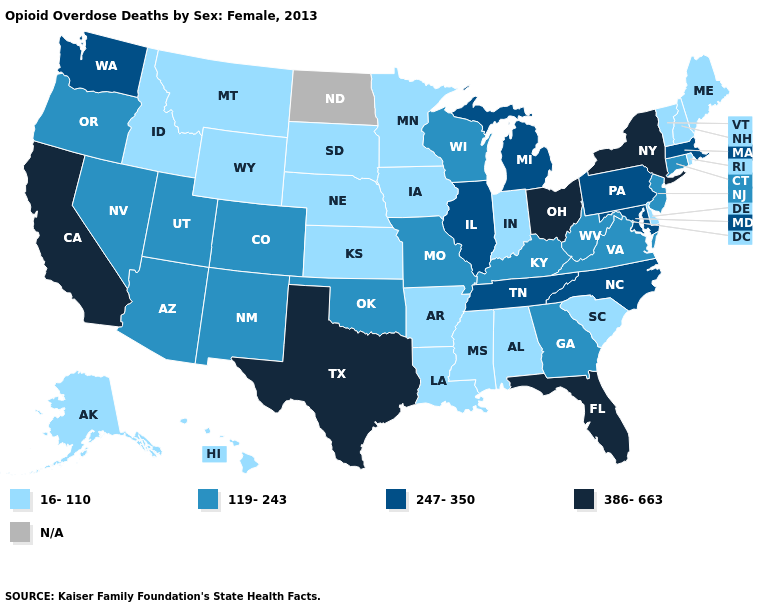Name the states that have a value in the range 16-110?
Keep it brief. Alabama, Alaska, Arkansas, Delaware, Hawaii, Idaho, Indiana, Iowa, Kansas, Louisiana, Maine, Minnesota, Mississippi, Montana, Nebraska, New Hampshire, Rhode Island, South Carolina, South Dakota, Vermont, Wyoming. Among the states that border Oregon , which have the highest value?
Concise answer only. California. Name the states that have a value in the range 119-243?
Keep it brief. Arizona, Colorado, Connecticut, Georgia, Kentucky, Missouri, Nevada, New Jersey, New Mexico, Oklahoma, Oregon, Utah, Virginia, West Virginia, Wisconsin. Name the states that have a value in the range 247-350?
Keep it brief. Illinois, Maryland, Massachusetts, Michigan, North Carolina, Pennsylvania, Tennessee, Washington. Name the states that have a value in the range 247-350?
Be succinct. Illinois, Maryland, Massachusetts, Michigan, North Carolina, Pennsylvania, Tennessee, Washington. Among the states that border New Mexico , which have the highest value?
Concise answer only. Texas. Name the states that have a value in the range 119-243?
Quick response, please. Arizona, Colorado, Connecticut, Georgia, Kentucky, Missouri, Nevada, New Jersey, New Mexico, Oklahoma, Oregon, Utah, Virginia, West Virginia, Wisconsin. Name the states that have a value in the range 119-243?
Quick response, please. Arizona, Colorado, Connecticut, Georgia, Kentucky, Missouri, Nevada, New Jersey, New Mexico, Oklahoma, Oregon, Utah, Virginia, West Virginia, Wisconsin. Does Idaho have the lowest value in the USA?
Write a very short answer. Yes. What is the highest value in states that border Michigan?
Answer briefly. 386-663. What is the value of Missouri?
Write a very short answer. 119-243. What is the value of New Jersey?
Quick response, please. 119-243. Name the states that have a value in the range 386-663?
Be succinct. California, Florida, New York, Ohio, Texas. What is the value of Massachusetts?
Write a very short answer. 247-350. 